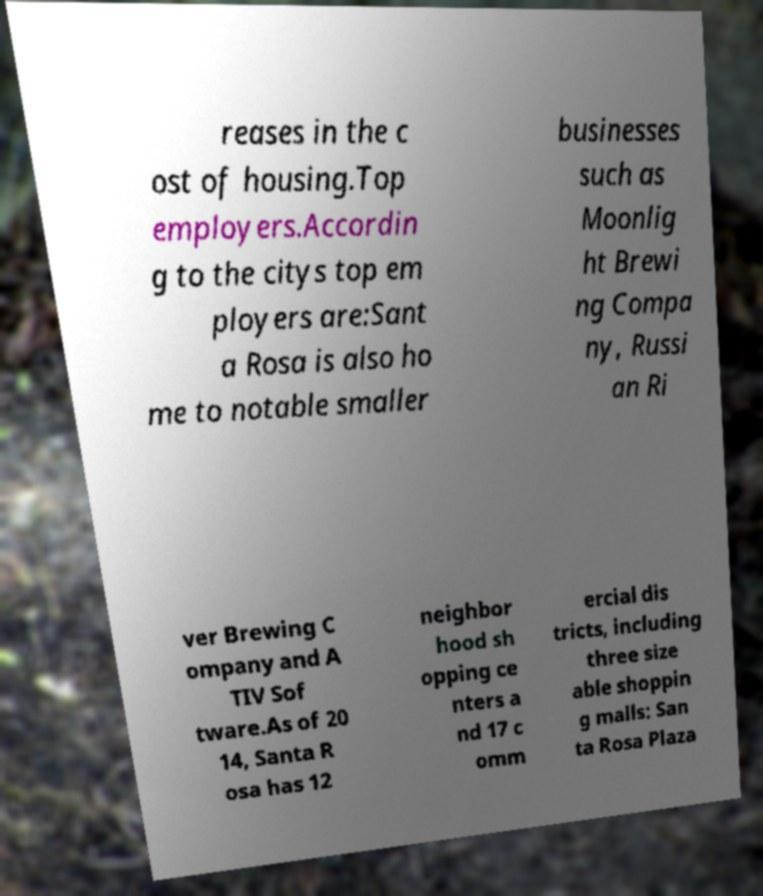Please read and relay the text visible in this image. What does it say? reases in the c ost of housing.Top employers.Accordin g to the citys top em ployers are:Sant a Rosa is also ho me to notable smaller businesses such as Moonlig ht Brewi ng Compa ny, Russi an Ri ver Brewing C ompany and A TIV Sof tware.As of 20 14, Santa R osa has 12 neighbor hood sh opping ce nters a nd 17 c omm ercial dis tricts, including three size able shoppin g malls: San ta Rosa Plaza 